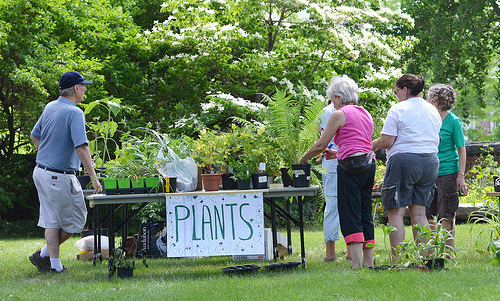<image>
Is there a grass in the lady? No. The grass is not contained within the lady. These objects have a different spatial relationship. Where is the plant in relation to the table? Is it on the table? Yes. Looking at the image, I can see the plant is positioned on top of the table, with the table providing support. 